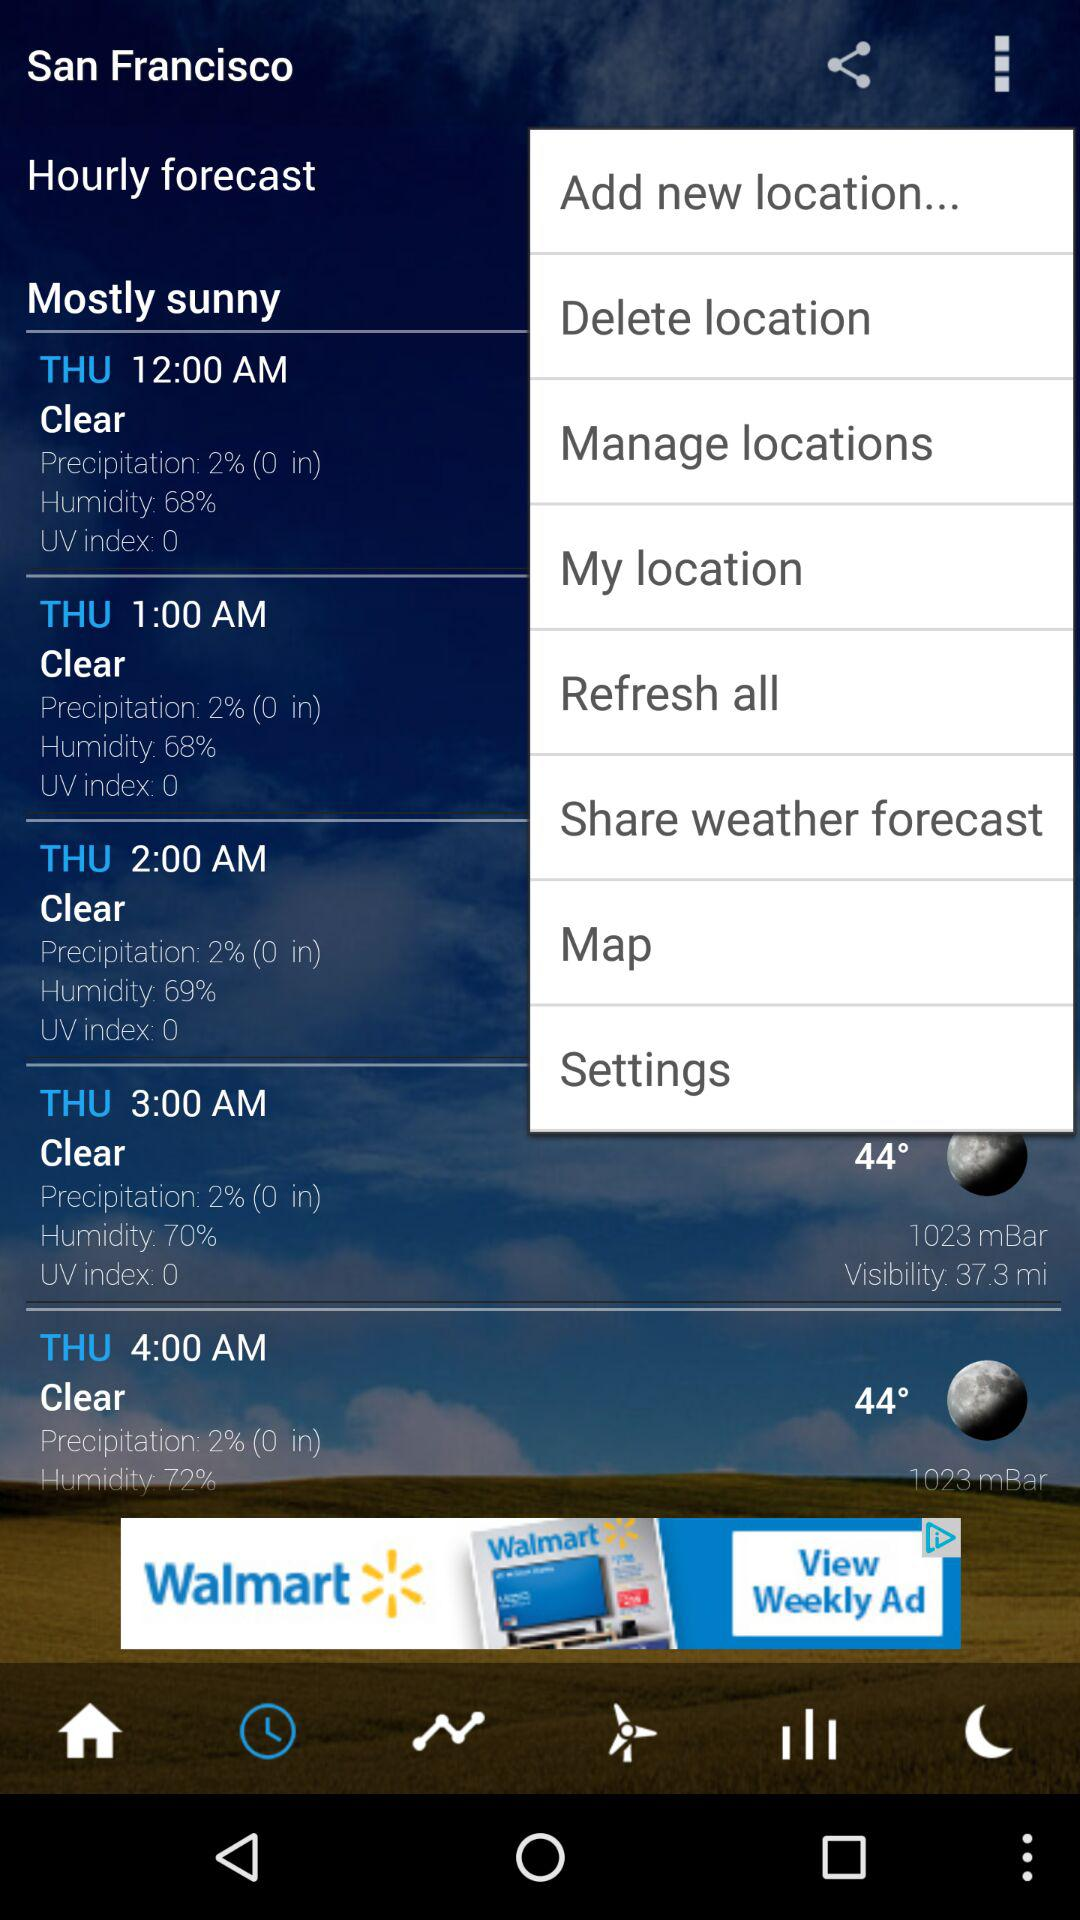What's the precipitation percentage at 4 am? The precipitation percentage is 2. 